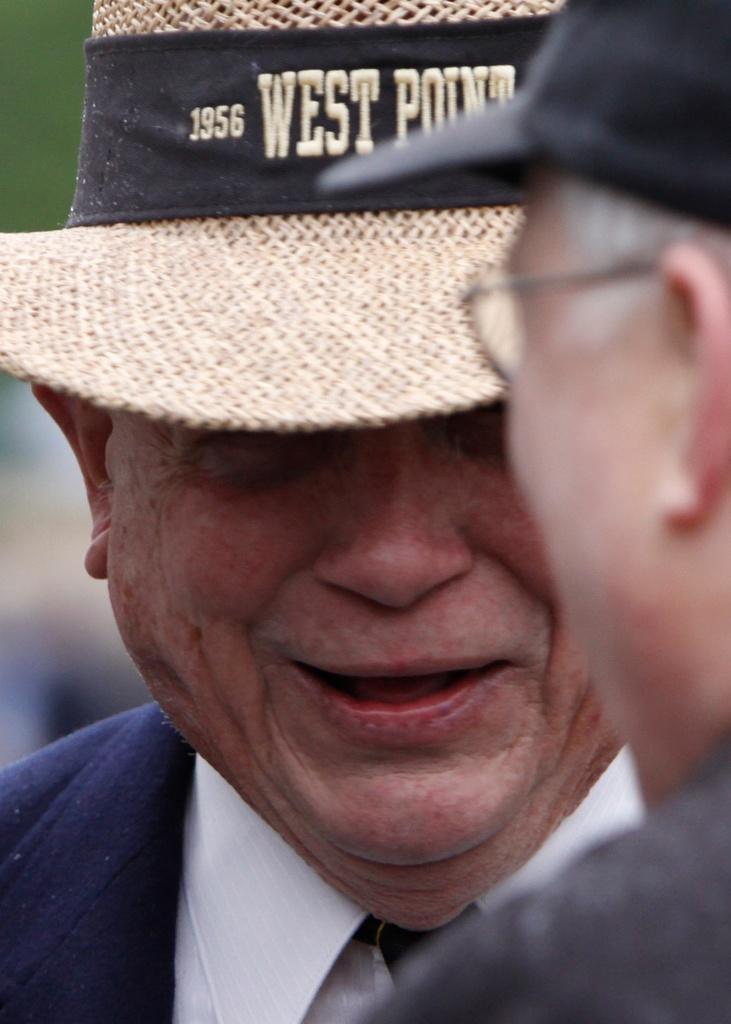How would you summarize this image in a sentence or two? In this image we can see two people with hats and a blurry background. 